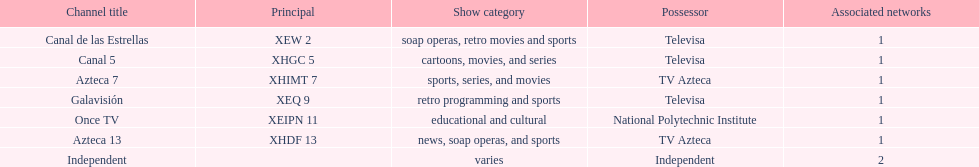What is the difference between the number of affiliates galavision has and the number of affiliates azteca 13 has? 0. 